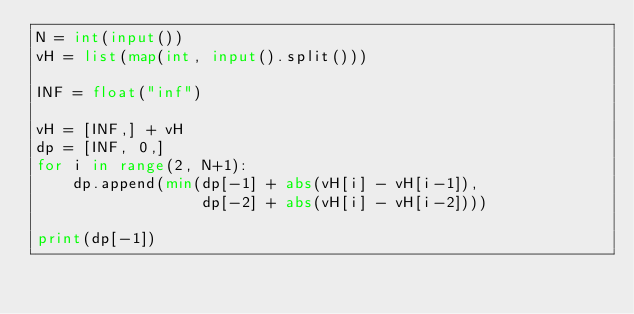<code> <loc_0><loc_0><loc_500><loc_500><_Python_>N = int(input())
vH = list(map(int, input().split()))

INF = float("inf")

vH = [INF,] + vH
dp = [INF, 0,]
for i in range(2, N+1):
    dp.append(min(dp[-1] + abs(vH[i] - vH[i-1]),
                  dp[-2] + abs(vH[i] - vH[i-2])))

print(dp[-1])
</code> 